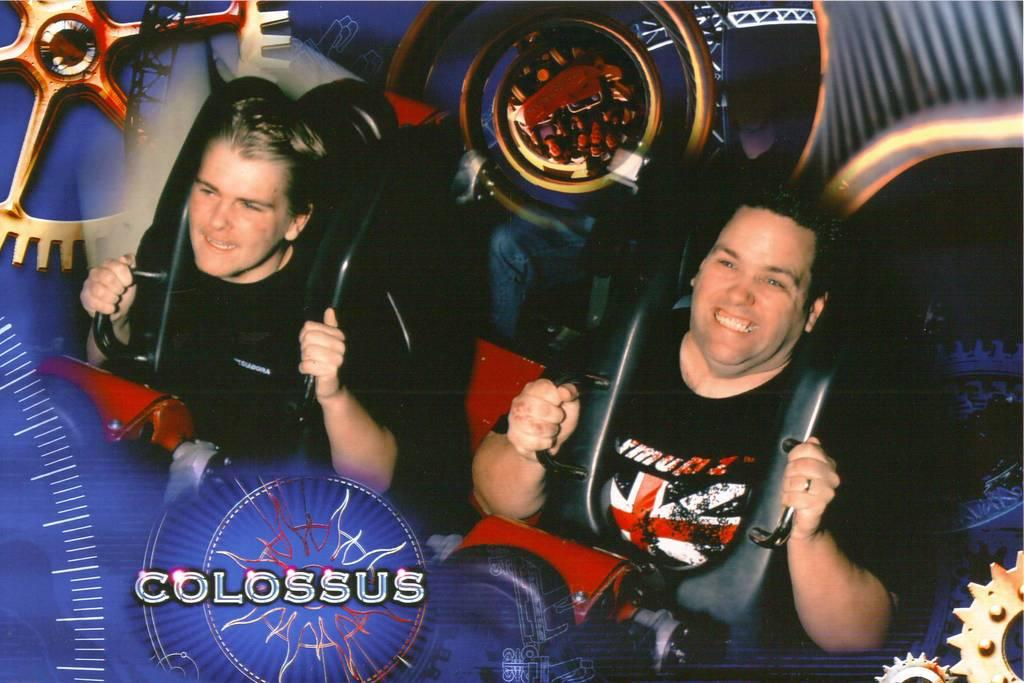How many people are in the image? There are two men in the image. What are the men doing in the image? The men are sitting and smiling. What safety feature is visible in the image? The men are wearing seatbelts. What else can be seen in the image besides the men? There are letters in the image. What country is depicted in the image? There is no country depicted in the image; it features two men sitting and smiling while wearing seatbelts. How does the health of the men in the image compare to each other? The health of the men cannot be determined from the image, as it only shows them sitting and smiling while wearing seatbelts. 